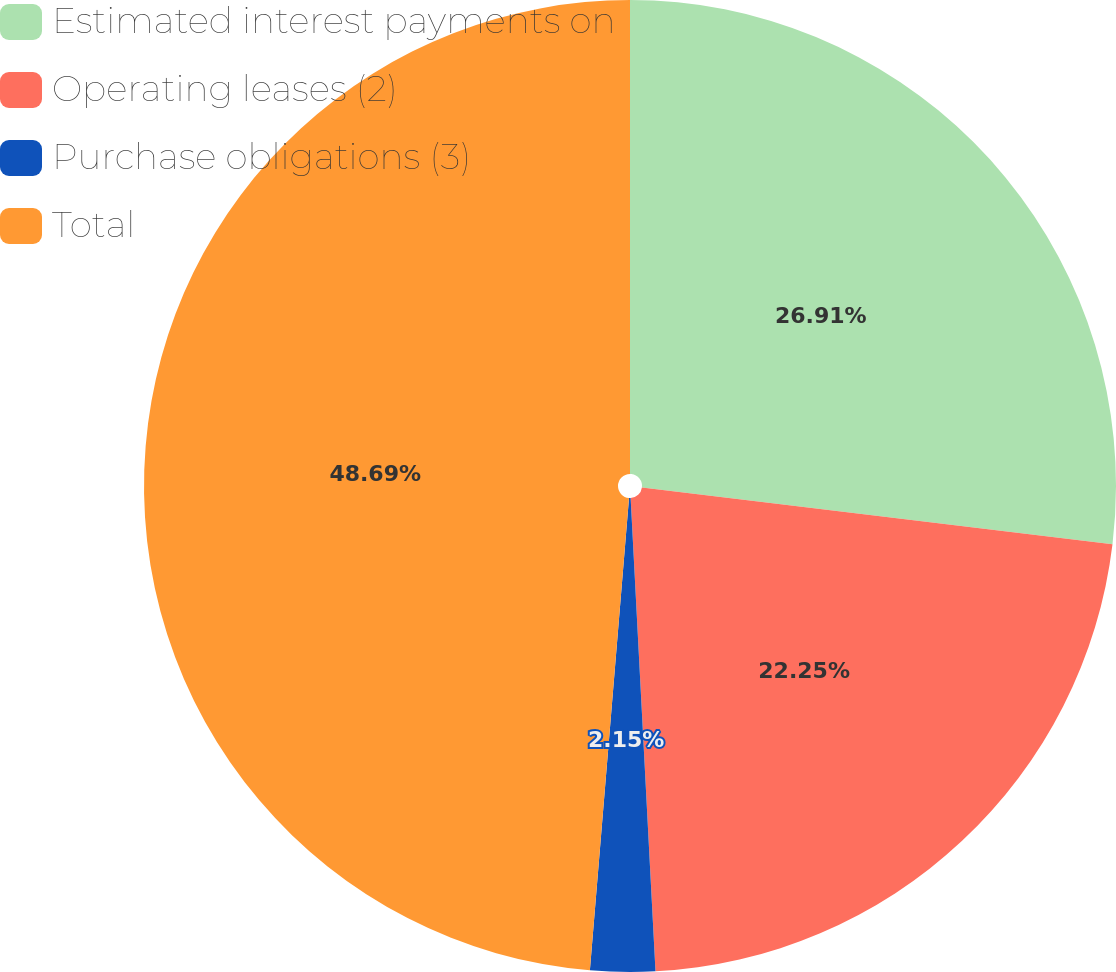<chart> <loc_0><loc_0><loc_500><loc_500><pie_chart><fcel>Estimated interest payments on<fcel>Operating leases (2)<fcel>Purchase obligations (3)<fcel>Total<nl><fcel>26.91%<fcel>22.25%<fcel>2.15%<fcel>48.68%<nl></chart> 